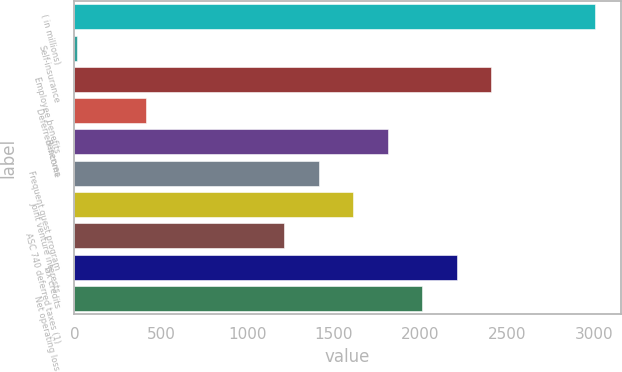Convert chart to OTSL. <chart><loc_0><loc_0><loc_500><loc_500><bar_chart><fcel>( in millions)<fcel>Self-insurance<fcel>Employee benefits<fcel>Deferred income<fcel>Reserves<fcel>Frequent guest program<fcel>Joint venture interests<fcel>ASC 740 deferred taxes (1)<fcel>Tax credits<fcel>Net operating loss<nl><fcel>3006<fcel>15<fcel>2407.8<fcel>413.8<fcel>1809.6<fcel>1410.8<fcel>1610.2<fcel>1211.4<fcel>2208.4<fcel>2009<nl></chart> 